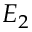<formula> <loc_0><loc_0><loc_500><loc_500>E _ { 2 }</formula> 